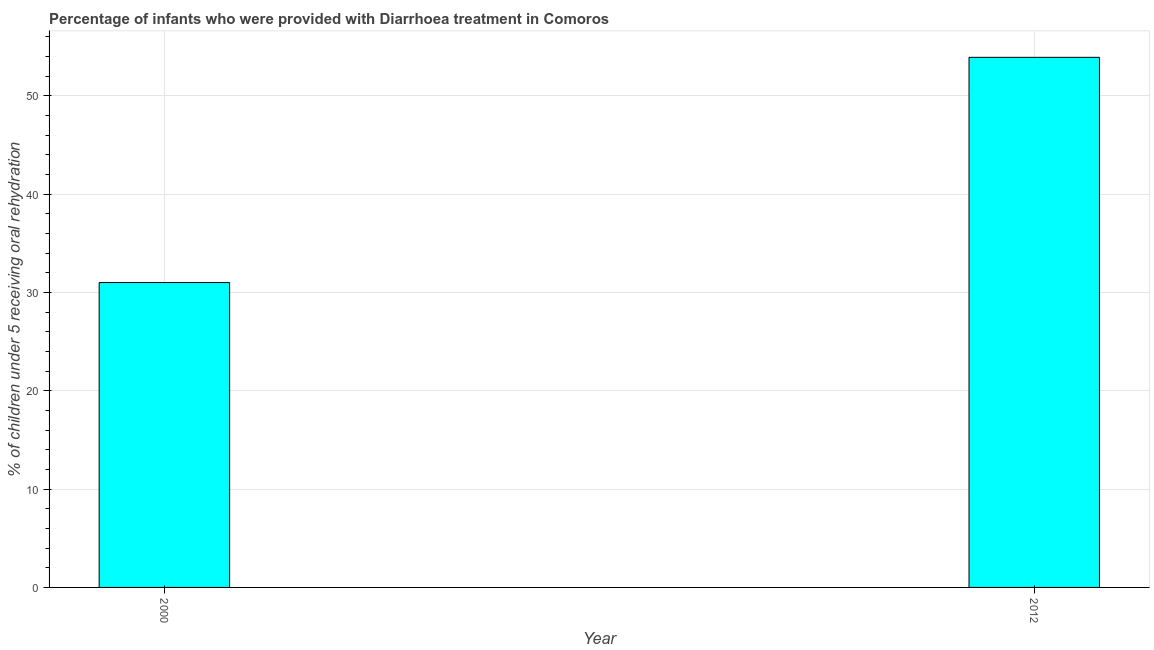What is the title of the graph?
Ensure brevity in your answer.  Percentage of infants who were provided with Diarrhoea treatment in Comoros. What is the label or title of the Y-axis?
Your answer should be compact. % of children under 5 receiving oral rehydration. What is the percentage of children who were provided with treatment diarrhoea in 2012?
Offer a terse response. 53.9. Across all years, what is the maximum percentage of children who were provided with treatment diarrhoea?
Give a very brief answer. 53.9. Across all years, what is the minimum percentage of children who were provided with treatment diarrhoea?
Ensure brevity in your answer.  31. What is the sum of the percentage of children who were provided with treatment diarrhoea?
Ensure brevity in your answer.  84.9. What is the difference between the percentage of children who were provided with treatment diarrhoea in 2000 and 2012?
Your answer should be compact. -22.9. What is the average percentage of children who were provided with treatment diarrhoea per year?
Your answer should be compact. 42.45. What is the median percentage of children who were provided with treatment diarrhoea?
Offer a very short reply. 42.45. What is the ratio of the percentage of children who were provided with treatment diarrhoea in 2000 to that in 2012?
Make the answer very short. 0.57. Is the percentage of children who were provided with treatment diarrhoea in 2000 less than that in 2012?
Offer a terse response. Yes. How many bars are there?
Give a very brief answer. 2. How many years are there in the graph?
Provide a succinct answer. 2. What is the difference between two consecutive major ticks on the Y-axis?
Your answer should be very brief. 10. What is the % of children under 5 receiving oral rehydration in 2012?
Your response must be concise. 53.9. What is the difference between the % of children under 5 receiving oral rehydration in 2000 and 2012?
Make the answer very short. -22.9. What is the ratio of the % of children under 5 receiving oral rehydration in 2000 to that in 2012?
Provide a short and direct response. 0.57. 